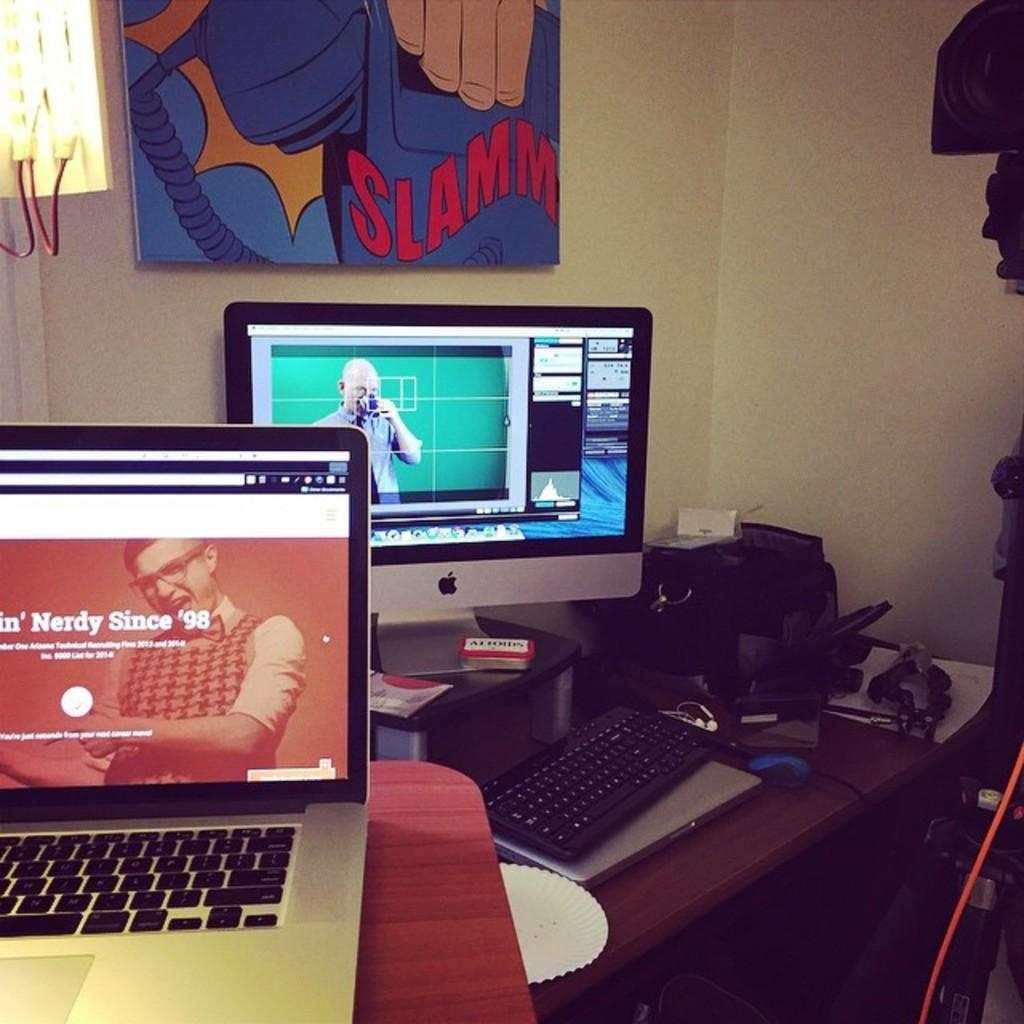What type of furniture is present in the image? There is a table in the image. What electronic device is on the table? There is a monitor on the table. What input device is on the table? There is a keyboard on the table. What additional piece of equipment is on the table? There is a printer machine on the table. What other electronic device is visible in the image? There is a laptop in the image. What type of chicken is sitting on the laptop in the image? There is no chicken present in the image; it only features a table with electronic devices and equipment. 